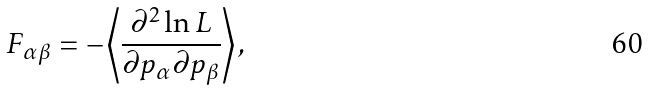Convert formula to latex. <formula><loc_0><loc_0><loc_500><loc_500>F _ { \alpha \beta } = - \left \langle \frac { \partial ^ { 2 } \ln L } { \partial p _ { \alpha } \partial p _ { \beta } } \right \rangle ,</formula> 